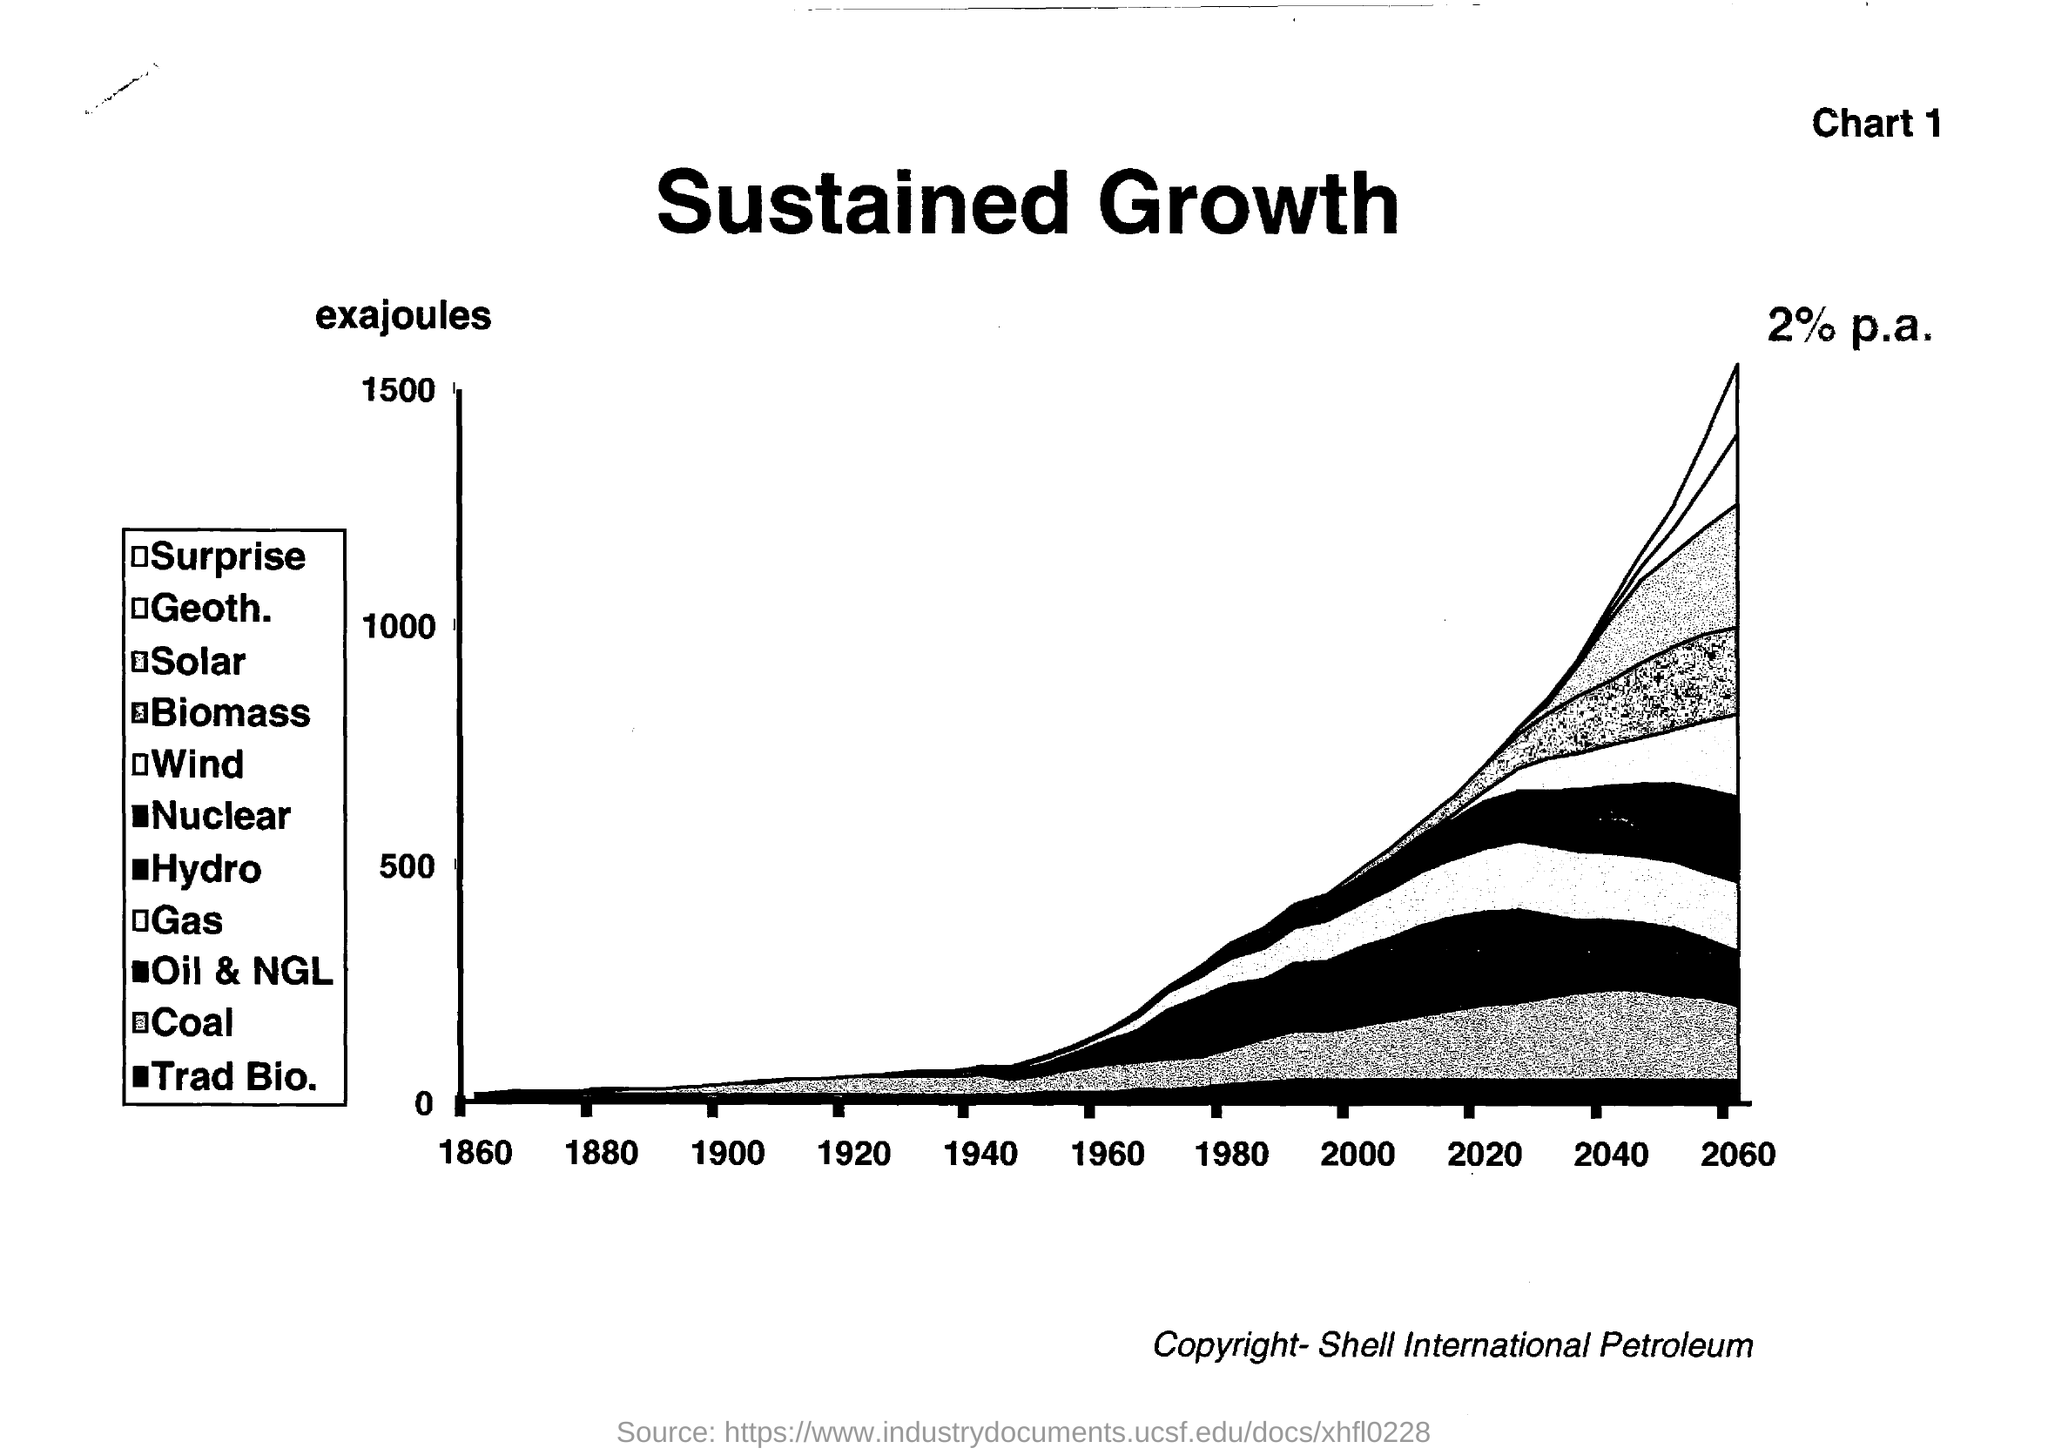Draw attention to some important aspects in this diagram. The title of the document is "Sustained Growth". 